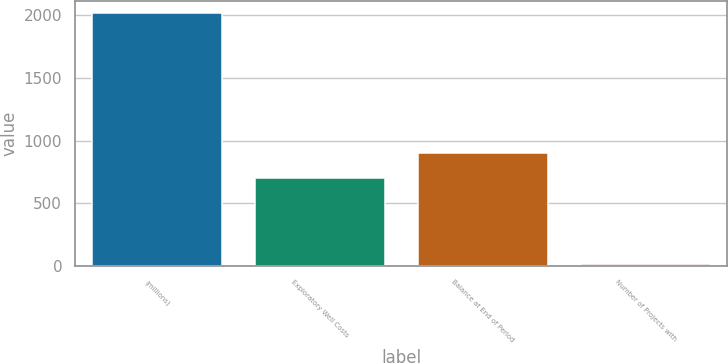Convert chart to OTSL. <chart><loc_0><loc_0><loc_500><loc_500><bar_chart><fcel>(millions)<fcel>Exploratory Well Costs<fcel>Balance at End of Period<fcel>Number of Projects with<nl><fcel>2016<fcel>699<fcel>899.6<fcel>10<nl></chart> 